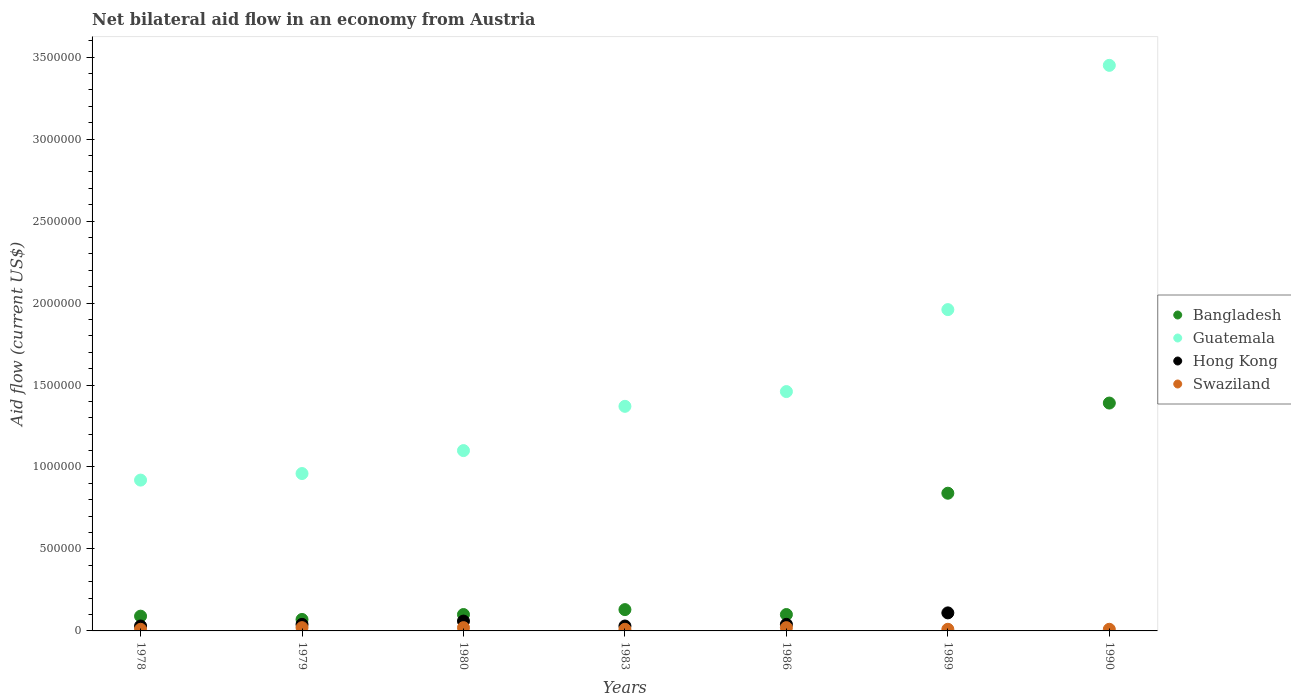Is the number of dotlines equal to the number of legend labels?
Give a very brief answer. No. Across all years, what is the maximum net bilateral aid flow in Guatemala?
Ensure brevity in your answer.  3.45e+06. What is the total net bilateral aid flow in Hong Kong in the graph?
Provide a succinct answer. 3.10e+05. What is the difference between the net bilateral aid flow in Guatemala in 1979 and the net bilateral aid flow in Swaziland in 1980?
Your response must be concise. 9.40e+05. What is the average net bilateral aid flow in Bangladesh per year?
Your response must be concise. 3.89e+05. In the year 1983, what is the difference between the net bilateral aid flow in Swaziland and net bilateral aid flow in Bangladesh?
Your answer should be compact. -1.20e+05. In how many years, is the net bilateral aid flow in Guatemala greater than 3100000 US$?
Give a very brief answer. 1. What is the ratio of the net bilateral aid flow in Bangladesh in 1978 to that in 1983?
Your answer should be very brief. 0.69. Is the net bilateral aid flow in Swaziland in 1983 less than that in 1990?
Offer a terse response. No. Is the difference between the net bilateral aid flow in Swaziland in 1989 and 1990 greater than the difference between the net bilateral aid flow in Bangladesh in 1989 and 1990?
Provide a short and direct response. Yes. What is the difference between the highest and the second highest net bilateral aid flow in Swaziland?
Give a very brief answer. 0. What is the difference between the highest and the lowest net bilateral aid flow in Guatemala?
Give a very brief answer. 2.53e+06. In how many years, is the net bilateral aid flow in Guatemala greater than the average net bilateral aid flow in Guatemala taken over all years?
Offer a terse response. 2. Is the sum of the net bilateral aid flow in Swaziland in 1983 and 1990 greater than the maximum net bilateral aid flow in Bangladesh across all years?
Ensure brevity in your answer.  No. Is it the case that in every year, the sum of the net bilateral aid flow in Guatemala and net bilateral aid flow in Bangladesh  is greater than the sum of net bilateral aid flow in Hong Kong and net bilateral aid flow in Swaziland?
Keep it short and to the point. No. Is the net bilateral aid flow in Hong Kong strictly greater than the net bilateral aid flow in Bangladesh over the years?
Your answer should be very brief. No. How many dotlines are there?
Give a very brief answer. 4. Are the values on the major ticks of Y-axis written in scientific E-notation?
Offer a terse response. No. Does the graph contain any zero values?
Your answer should be compact. Yes. How many legend labels are there?
Your answer should be very brief. 4. How are the legend labels stacked?
Keep it short and to the point. Vertical. What is the title of the graph?
Your response must be concise. Net bilateral aid flow in an economy from Austria. Does "Montenegro" appear as one of the legend labels in the graph?
Offer a very short reply. No. What is the label or title of the X-axis?
Give a very brief answer. Years. What is the Aid flow (current US$) of Bangladesh in 1978?
Provide a short and direct response. 9.00e+04. What is the Aid flow (current US$) of Guatemala in 1978?
Offer a terse response. 9.20e+05. What is the Aid flow (current US$) in Guatemala in 1979?
Provide a succinct answer. 9.60e+05. What is the Aid flow (current US$) of Hong Kong in 1979?
Provide a succinct answer. 4.00e+04. What is the Aid flow (current US$) of Swaziland in 1979?
Ensure brevity in your answer.  2.00e+04. What is the Aid flow (current US$) of Bangladesh in 1980?
Keep it short and to the point. 1.00e+05. What is the Aid flow (current US$) in Guatemala in 1980?
Your response must be concise. 1.10e+06. What is the Aid flow (current US$) in Hong Kong in 1980?
Provide a short and direct response. 6.00e+04. What is the Aid flow (current US$) in Guatemala in 1983?
Your response must be concise. 1.37e+06. What is the Aid flow (current US$) of Guatemala in 1986?
Provide a short and direct response. 1.46e+06. What is the Aid flow (current US$) in Swaziland in 1986?
Offer a terse response. 2.00e+04. What is the Aid flow (current US$) of Bangladesh in 1989?
Ensure brevity in your answer.  8.40e+05. What is the Aid flow (current US$) of Guatemala in 1989?
Keep it short and to the point. 1.96e+06. What is the Aid flow (current US$) in Bangladesh in 1990?
Offer a terse response. 1.39e+06. What is the Aid flow (current US$) of Guatemala in 1990?
Offer a very short reply. 3.45e+06. Across all years, what is the maximum Aid flow (current US$) in Bangladesh?
Your answer should be compact. 1.39e+06. Across all years, what is the maximum Aid flow (current US$) in Guatemala?
Keep it short and to the point. 3.45e+06. Across all years, what is the maximum Aid flow (current US$) in Hong Kong?
Keep it short and to the point. 1.10e+05. Across all years, what is the maximum Aid flow (current US$) in Swaziland?
Provide a short and direct response. 2.00e+04. Across all years, what is the minimum Aid flow (current US$) of Guatemala?
Your answer should be compact. 9.20e+05. What is the total Aid flow (current US$) in Bangladesh in the graph?
Your response must be concise. 2.72e+06. What is the total Aid flow (current US$) of Guatemala in the graph?
Offer a very short reply. 1.12e+07. What is the total Aid flow (current US$) in Swaziland in the graph?
Your answer should be very brief. 1.00e+05. What is the difference between the Aid flow (current US$) in Hong Kong in 1978 and that in 1979?
Your answer should be very brief. -10000. What is the difference between the Aid flow (current US$) of Swaziland in 1978 and that in 1979?
Your answer should be compact. -10000. What is the difference between the Aid flow (current US$) in Bangladesh in 1978 and that in 1980?
Your response must be concise. -10000. What is the difference between the Aid flow (current US$) in Guatemala in 1978 and that in 1980?
Provide a succinct answer. -1.80e+05. What is the difference between the Aid flow (current US$) in Guatemala in 1978 and that in 1983?
Give a very brief answer. -4.50e+05. What is the difference between the Aid flow (current US$) in Hong Kong in 1978 and that in 1983?
Your response must be concise. 0. What is the difference between the Aid flow (current US$) in Swaziland in 1978 and that in 1983?
Provide a succinct answer. 0. What is the difference between the Aid flow (current US$) in Bangladesh in 1978 and that in 1986?
Your answer should be compact. -10000. What is the difference between the Aid flow (current US$) in Guatemala in 1978 and that in 1986?
Offer a terse response. -5.40e+05. What is the difference between the Aid flow (current US$) in Swaziland in 1978 and that in 1986?
Offer a very short reply. -10000. What is the difference between the Aid flow (current US$) of Bangladesh in 1978 and that in 1989?
Keep it short and to the point. -7.50e+05. What is the difference between the Aid flow (current US$) of Guatemala in 1978 and that in 1989?
Give a very brief answer. -1.04e+06. What is the difference between the Aid flow (current US$) of Bangladesh in 1978 and that in 1990?
Ensure brevity in your answer.  -1.30e+06. What is the difference between the Aid flow (current US$) of Guatemala in 1978 and that in 1990?
Your answer should be very brief. -2.53e+06. What is the difference between the Aid flow (current US$) of Hong Kong in 1979 and that in 1980?
Ensure brevity in your answer.  -2.00e+04. What is the difference between the Aid flow (current US$) of Swaziland in 1979 and that in 1980?
Keep it short and to the point. 0. What is the difference between the Aid flow (current US$) of Guatemala in 1979 and that in 1983?
Ensure brevity in your answer.  -4.10e+05. What is the difference between the Aid flow (current US$) in Guatemala in 1979 and that in 1986?
Provide a short and direct response. -5.00e+05. What is the difference between the Aid flow (current US$) in Swaziland in 1979 and that in 1986?
Your answer should be compact. 0. What is the difference between the Aid flow (current US$) in Bangladesh in 1979 and that in 1989?
Provide a short and direct response. -7.70e+05. What is the difference between the Aid flow (current US$) in Hong Kong in 1979 and that in 1989?
Give a very brief answer. -7.00e+04. What is the difference between the Aid flow (current US$) of Bangladesh in 1979 and that in 1990?
Your answer should be compact. -1.32e+06. What is the difference between the Aid flow (current US$) of Guatemala in 1979 and that in 1990?
Make the answer very short. -2.49e+06. What is the difference between the Aid flow (current US$) in Swaziland in 1979 and that in 1990?
Make the answer very short. 10000. What is the difference between the Aid flow (current US$) of Bangladesh in 1980 and that in 1983?
Your answer should be very brief. -3.00e+04. What is the difference between the Aid flow (current US$) in Guatemala in 1980 and that in 1983?
Your answer should be compact. -2.70e+05. What is the difference between the Aid flow (current US$) in Bangladesh in 1980 and that in 1986?
Offer a very short reply. 0. What is the difference between the Aid flow (current US$) in Guatemala in 1980 and that in 1986?
Make the answer very short. -3.60e+05. What is the difference between the Aid flow (current US$) of Hong Kong in 1980 and that in 1986?
Offer a very short reply. 2.00e+04. What is the difference between the Aid flow (current US$) in Swaziland in 1980 and that in 1986?
Give a very brief answer. 0. What is the difference between the Aid flow (current US$) of Bangladesh in 1980 and that in 1989?
Your response must be concise. -7.40e+05. What is the difference between the Aid flow (current US$) in Guatemala in 1980 and that in 1989?
Your answer should be compact. -8.60e+05. What is the difference between the Aid flow (current US$) of Swaziland in 1980 and that in 1989?
Offer a terse response. 10000. What is the difference between the Aid flow (current US$) of Bangladesh in 1980 and that in 1990?
Give a very brief answer. -1.29e+06. What is the difference between the Aid flow (current US$) of Guatemala in 1980 and that in 1990?
Your answer should be very brief. -2.35e+06. What is the difference between the Aid flow (current US$) of Swaziland in 1980 and that in 1990?
Provide a succinct answer. 10000. What is the difference between the Aid flow (current US$) of Hong Kong in 1983 and that in 1986?
Keep it short and to the point. -10000. What is the difference between the Aid flow (current US$) of Swaziland in 1983 and that in 1986?
Provide a succinct answer. -10000. What is the difference between the Aid flow (current US$) in Bangladesh in 1983 and that in 1989?
Offer a very short reply. -7.10e+05. What is the difference between the Aid flow (current US$) of Guatemala in 1983 and that in 1989?
Make the answer very short. -5.90e+05. What is the difference between the Aid flow (current US$) of Hong Kong in 1983 and that in 1989?
Ensure brevity in your answer.  -8.00e+04. What is the difference between the Aid flow (current US$) in Swaziland in 1983 and that in 1989?
Your answer should be compact. 0. What is the difference between the Aid flow (current US$) in Bangladesh in 1983 and that in 1990?
Your answer should be very brief. -1.26e+06. What is the difference between the Aid flow (current US$) in Guatemala in 1983 and that in 1990?
Offer a terse response. -2.08e+06. What is the difference between the Aid flow (current US$) in Swaziland in 1983 and that in 1990?
Give a very brief answer. 0. What is the difference between the Aid flow (current US$) in Bangladesh in 1986 and that in 1989?
Your answer should be very brief. -7.40e+05. What is the difference between the Aid flow (current US$) in Guatemala in 1986 and that in 1989?
Ensure brevity in your answer.  -5.00e+05. What is the difference between the Aid flow (current US$) of Bangladesh in 1986 and that in 1990?
Offer a terse response. -1.29e+06. What is the difference between the Aid flow (current US$) in Guatemala in 1986 and that in 1990?
Your answer should be compact. -1.99e+06. What is the difference between the Aid flow (current US$) in Bangladesh in 1989 and that in 1990?
Provide a short and direct response. -5.50e+05. What is the difference between the Aid flow (current US$) of Guatemala in 1989 and that in 1990?
Give a very brief answer. -1.49e+06. What is the difference between the Aid flow (current US$) of Bangladesh in 1978 and the Aid flow (current US$) of Guatemala in 1979?
Make the answer very short. -8.70e+05. What is the difference between the Aid flow (current US$) of Guatemala in 1978 and the Aid flow (current US$) of Hong Kong in 1979?
Provide a short and direct response. 8.80e+05. What is the difference between the Aid flow (current US$) in Guatemala in 1978 and the Aid flow (current US$) in Swaziland in 1979?
Provide a succinct answer. 9.00e+05. What is the difference between the Aid flow (current US$) in Bangladesh in 1978 and the Aid flow (current US$) in Guatemala in 1980?
Provide a succinct answer. -1.01e+06. What is the difference between the Aid flow (current US$) of Bangladesh in 1978 and the Aid flow (current US$) of Hong Kong in 1980?
Provide a succinct answer. 3.00e+04. What is the difference between the Aid flow (current US$) of Guatemala in 1978 and the Aid flow (current US$) of Hong Kong in 1980?
Keep it short and to the point. 8.60e+05. What is the difference between the Aid flow (current US$) of Hong Kong in 1978 and the Aid flow (current US$) of Swaziland in 1980?
Provide a short and direct response. 10000. What is the difference between the Aid flow (current US$) in Bangladesh in 1978 and the Aid flow (current US$) in Guatemala in 1983?
Provide a succinct answer. -1.28e+06. What is the difference between the Aid flow (current US$) of Bangladesh in 1978 and the Aid flow (current US$) of Hong Kong in 1983?
Offer a very short reply. 6.00e+04. What is the difference between the Aid flow (current US$) of Bangladesh in 1978 and the Aid flow (current US$) of Swaziland in 1983?
Your answer should be compact. 8.00e+04. What is the difference between the Aid flow (current US$) of Guatemala in 1978 and the Aid flow (current US$) of Hong Kong in 1983?
Provide a succinct answer. 8.90e+05. What is the difference between the Aid flow (current US$) of Guatemala in 1978 and the Aid flow (current US$) of Swaziland in 1983?
Offer a terse response. 9.10e+05. What is the difference between the Aid flow (current US$) in Hong Kong in 1978 and the Aid flow (current US$) in Swaziland in 1983?
Provide a succinct answer. 2.00e+04. What is the difference between the Aid flow (current US$) in Bangladesh in 1978 and the Aid flow (current US$) in Guatemala in 1986?
Provide a short and direct response. -1.37e+06. What is the difference between the Aid flow (current US$) of Bangladesh in 1978 and the Aid flow (current US$) of Swaziland in 1986?
Give a very brief answer. 7.00e+04. What is the difference between the Aid flow (current US$) of Guatemala in 1978 and the Aid flow (current US$) of Hong Kong in 1986?
Offer a very short reply. 8.80e+05. What is the difference between the Aid flow (current US$) of Guatemala in 1978 and the Aid flow (current US$) of Swaziland in 1986?
Offer a very short reply. 9.00e+05. What is the difference between the Aid flow (current US$) in Hong Kong in 1978 and the Aid flow (current US$) in Swaziland in 1986?
Ensure brevity in your answer.  10000. What is the difference between the Aid flow (current US$) in Bangladesh in 1978 and the Aid flow (current US$) in Guatemala in 1989?
Make the answer very short. -1.87e+06. What is the difference between the Aid flow (current US$) in Bangladesh in 1978 and the Aid flow (current US$) in Swaziland in 1989?
Offer a very short reply. 8.00e+04. What is the difference between the Aid flow (current US$) of Guatemala in 1978 and the Aid flow (current US$) of Hong Kong in 1989?
Your response must be concise. 8.10e+05. What is the difference between the Aid flow (current US$) of Guatemala in 1978 and the Aid flow (current US$) of Swaziland in 1989?
Your response must be concise. 9.10e+05. What is the difference between the Aid flow (current US$) in Bangladesh in 1978 and the Aid flow (current US$) in Guatemala in 1990?
Keep it short and to the point. -3.36e+06. What is the difference between the Aid flow (current US$) in Guatemala in 1978 and the Aid flow (current US$) in Swaziland in 1990?
Your answer should be very brief. 9.10e+05. What is the difference between the Aid flow (current US$) of Hong Kong in 1978 and the Aid flow (current US$) of Swaziland in 1990?
Provide a succinct answer. 2.00e+04. What is the difference between the Aid flow (current US$) of Bangladesh in 1979 and the Aid flow (current US$) of Guatemala in 1980?
Give a very brief answer. -1.03e+06. What is the difference between the Aid flow (current US$) in Guatemala in 1979 and the Aid flow (current US$) in Hong Kong in 1980?
Provide a succinct answer. 9.00e+05. What is the difference between the Aid flow (current US$) of Guatemala in 1979 and the Aid flow (current US$) of Swaziland in 1980?
Provide a short and direct response. 9.40e+05. What is the difference between the Aid flow (current US$) in Bangladesh in 1979 and the Aid flow (current US$) in Guatemala in 1983?
Make the answer very short. -1.30e+06. What is the difference between the Aid flow (current US$) in Bangladesh in 1979 and the Aid flow (current US$) in Swaziland in 1983?
Provide a short and direct response. 6.00e+04. What is the difference between the Aid flow (current US$) of Guatemala in 1979 and the Aid flow (current US$) of Hong Kong in 1983?
Give a very brief answer. 9.30e+05. What is the difference between the Aid flow (current US$) of Guatemala in 1979 and the Aid flow (current US$) of Swaziland in 1983?
Offer a terse response. 9.50e+05. What is the difference between the Aid flow (current US$) of Hong Kong in 1979 and the Aid flow (current US$) of Swaziland in 1983?
Offer a very short reply. 3.00e+04. What is the difference between the Aid flow (current US$) in Bangladesh in 1979 and the Aid flow (current US$) in Guatemala in 1986?
Give a very brief answer. -1.39e+06. What is the difference between the Aid flow (current US$) of Guatemala in 1979 and the Aid flow (current US$) of Hong Kong in 1986?
Provide a succinct answer. 9.20e+05. What is the difference between the Aid flow (current US$) in Guatemala in 1979 and the Aid flow (current US$) in Swaziland in 1986?
Provide a succinct answer. 9.40e+05. What is the difference between the Aid flow (current US$) of Bangladesh in 1979 and the Aid flow (current US$) of Guatemala in 1989?
Your response must be concise. -1.89e+06. What is the difference between the Aid flow (current US$) in Guatemala in 1979 and the Aid flow (current US$) in Hong Kong in 1989?
Your response must be concise. 8.50e+05. What is the difference between the Aid flow (current US$) of Guatemala in 1979 and the Aid flow (current US$) of Swaziland in 1989?
Give a very brief answer. 9.50e+05. What is the difference between the Aid flow (current US$) of Bangladesh in 1979 and the Aid flow (current US$) of Guatemala in 1990?
Your answer should be compact. -3.38e+06. What is the difference between the Aid flow (current US$) of Bangladesh in 1979 and the Aid flow (current US$) of Swaziland in 1990?
Your answer should be very brief. 6.00e+04. What is the difference between the Aid flow (current US$) of Guatemala in 1979 and the Aid flow (current US$) of Swaziland in 1990?
Give a very brief answer. 9.50e+05. What is the difference between the Aid flow (current US$) in Bangladesh in 1980 and the Aid flow (current US$) in Guatemala in 1983?
Make the answer very short. -1.27e+06. What is the difference between the Aid flow (current US$) of Bangladesh in 1980 and the Aid flow (current US$) of Hong Kong in 1983?
Your answer should be compact. 7.00e+04. What is the difference between the Aid flow (current US$) of Guatemala in 1980 and the Aid flow (current US$) of Hong Kong in 1983?
Your response must be concise. 1.07e+06. What is the difference between the Aid flow (current US$) of Guatemala in 1980 and the Aid flow (current US$) of Swaziland in 1983?
Make the answer very short. 1.09e+06. What is the difference between the Aid flow (current US$) in Hong Kong in 1980 and the Aid flow (current US$) in Swaziland in 1983?
Your answer should be very brief. 5.00e+04. What is the difference between the Aid flow (current US$) in Bangladesh in 1980 and the Aid flow (current US$) in Guatemala in 1986?
Make the answer very short. -1.36e+06. What is the difference between the Aid flow (current US$) in Bangladesh in 1980 and the Aid flow (current US$) in Swaziland in 1986?
Ensure brevity in your answer.  8.00e+04. What is the difference between the Aid flow (current US$) of Guatemala in 1980 and the Aid flow (current US$) of Hong Kong in 1986?
Your response must be concise. 1.06e+06. What is the difference between the Aid flow (current US$) of Guatemala in 1980 and the Aid flow (current US$) of Swaziland in 1986?
Offer a very short reply. 1.08e+06. What is the difference between the Aid flow (current US$) of Bangladesh in 1980 and the Aid flow (current US$) of Guatemala in 1989?
Ensure brevity in your answer.  -1.86e+06. What is the difference between the Aid flow (current US$) in Bangladesh in 1980 and the Aid flow (current US$) in Swaziland in 1989?
Your answer should be compact. 9.00e+04. What is the difference between the Aid flow (current US$) in Guatemala in 1980 and the Aid flow (current US$) in Hong Kong in 1989?
Ensure brevity in your answer.  9.90e+05. What is the difference between the Aid flow (current US$) of Guatemala in 1980 and the Aid flow (current US$) of Swaziland in 1989?
Ensure brevity in your answer.  1.09e+06. What is the difference between the Aid flow (current US$) of Hong Kong in 1980 and the Aid flow (current US$) of Swaziland in 1989?
Offer a terse response. 5.00e+04. What is the difference between the Aid flow (current US$) in Bangladesh in 1980 and the Aid flow (current US$) in Guatemala in 1990?
Offer a terse response. -3.35e+06. What is the difference between the Aid flow (current US$) in Bangladesh in 1980 and the Aid flow (current US$) in Swaziland in 1990?
Give a very brief answer. 9.00e+04. What is the difference between the Aid flow (current US$) of Guatemala in 1980 and the Aid flow (current US$) of Swaziland in 1990?
Keep it short and to the point. 1.09e+06. What is the difference between the Aid flow (current US$) of Hong Kong in 1980 and the Aid flow (current US$) of Swaziland in 1990?
Offer a very short reply. 5.00e+04. What is the difference between the Aid flow (current US$) of Bangladesh in 1983 and the Aid flow (current US$) of Guatemala in 1986?
Provide a short and direct response. -1.33e+06. What is the difference between the Aid flow (current US$) in Bangladesh in 1983 and the Aid flow (current US$) in Hong Kong in 1986?
Make the answer very short. 9.00e+04. What is the difference between the Aid flow (current US$) of Guatemala in 1983 and the Aid flow (current US$) of Hong Kong in 1986?
Offer a terse response. 1.33e+06. What is the difference between the Aid flow (current US$) of Guatemala in 1983 and the Aid flow (current US$) of Swaziland in 1986?
Your response must be concise. 1.35e+06. What is the difference between the Aid flow (current US$) of Hong Kong in 1983 and the Aid flow (current US$) of Swaziland in 1986?
Keep it short and to the point. 10000. What is the difference between the Aid flow (current US$) in Bangladesh in 1983 and the Aid flow (current US$) in Guatemala in 1989?
Ensure brevity in your answer.  -1.83e+06. What is the difference between the Aid flow (current US$) of Bangladesh in 1983 and the Aid flow (current US$) of Hong Kong in 1989?
Offer a terse response. 2.00e+04. What is the difference between the Aid flow (current US$) in Guatemala in 1983 and the Aid flow (current US$) in Hong Kong in 1989?
Provide a short and direct response. 1.26e+06. What is the difference between the Aid flow (current US$) of Guatemala in 1983 and the Aid flow (current US$) of Swaziland in 1989?
Offer a terse response. 1.36e+06. What is the difference between the Aid flow (current US$) of Hong Kong in 1983 and the Aid flow (current US$) of Swaziland in 1989?
Offer a very short reply. 2.00e+04. What is the difference between the Aid flow (current US$) in Bangladesh in 1983 and the Aid flow (current US$) in Guatemala in 1990?
Keep it short and to the point. -3.32e+06. What is the difference between the Aid flow (current US$) in Bangladesh in 1983 and the Aid flow (current US$) in Swaziland in 1990?
Make the answer very short. 1.20e+05. What is the difference between the Aid flow (current US$) of Guatemala in 1983 and the Aid flow (current US$) of Swaziland in 1990?
Make the answer very short. 1.36e+06. What is the difference between the Aid flow (current US$) of Hong Kong in 1983 and the Aid flow (current US$) of Swaziland in 1990?
Your response must be concise. 2.00e+04. What is the difference between the Aid flow (current US$) of Bangladesh in 1986 and the Aid flow (current US$) of Guatemala in 1989?
Make the answer very short. -1.86e+06. What is the difference between the Aid flow (current US$) of Guatemala in 1986 and the Aid flow (current US$) of Hong Kong in 1989?
Ensure brevity in your answer.  1.35e+06. What is the difference between the Aid flow (current US$) in Guatemala in 1986 and the Aid flow (current US$) in Swaziland in 1989?
Your response must be concise. 1.45e+06. What is the difference between the Aid flow (current US$) of Hong Kong in 1986 and the Aid flow (current US$) of Swaziland in 1989?
Your answer should be compact. 3.00e+04. What is the difference between the Aid flow (current US$) in Bangladesh in 1986 and the Aid flow (current US$) in Guatemala in 1990?
Make the answer very short. -3.35e+06. What is the difference between the Aid flow (current US$) of Bangladesh in 1986 and the Aid flow (current US$) of Swaziland in 1990?
Your response must be concise. 9.00e+04. What is the difference between the Aid flow (current US$) in Guatemala in 1986 and the Aid flow (current US$) in Swaziland in 1990?
Ensure brevity in your answer.  1.45e+06. What is the difference between the Aid flow (current US$) of Hong Kong in 1986 and the Aid flow (current US$) of Swaziland in 1990?
Ensure brevity in your answer.  3.00e+04. What is the difference between the Aid flow (current US$) of Bangladesh in 1989 and the Aid flow (current US$) of Guatemala in 1990?
Ensure brevity in your answer.  -2.61e+06. What is the difference between the Aid flow (current US$) in Bangladesh in 1989 and the Aid flow (current US$) in Swaziland in 1990?
Offer a very short reply. 8.30e+05. What is the difference between the Aid flow (current US$) in Guatemala in 1989 and the Aid flow (current US$) in Swaziland in 1990?
Keep it short and to the point. 1.95e+06. What is the average Aid flow (current US$) of Bangladesh per year?
Your answer should be compact. 3.89e+05. What is the average Aid flow (current US$) in Guatemala per year?
Your answer should be compact. 1.60e+06. What is the average Aid flow (current US$) of Hong Kong per year?
Give a very brief answer. 4.43e+04. What is the average Aid flow (current US$) of Swaziland per year?
Provide a succinct answer. 1.43e+04. In the year 1978, what is the difference between the Aid flow (current US$) in Bangladesh and Aid flow (current US$) in Guatemala?
Offer a terse response. -8.30e+05. In the year 1978, what is the difference between the Aid flow (current US$) of Bangladesh and Aid flow (current US$) of Swaziland?
Provide a succinct answer. 8.00e+04. In the year 1978, what is the difference between the Aid flow (current US$) of Guatemala and Aid flow (current US$) of Hong Kong?
Offer a terse response. 8.90e+05. In the year 1978, what is the difference between the Aid flow (current US$) in Guatemala and Aid flow (current US$) in Swaziland?
Provide a succinct answer. 9.10e+05. In the year 1978, what is the difference between the Aid flow (current US$) of Hong Kong and Aid flow (current US$) of Swaziland?
Make the answer very short. 2.00e+04. In the year 1979, what is the difference between the Aid flow (current US$) of Bangladesh and Aid flow (current US$) of Guatemala?
Provide a short and direct response. -8.90e+05. In the year 1979, what is the difference between the Aid flow (current US$) of Bangladesh and Aid flow (current US$) of Swaziland?
Offer a very short reply. 5.00e+04. In the year 1979, what is the difference between the Aid flow (current US$) of Guatemala and Aid flow (current US$) of Hong Kong?
Keep it short and to the point. 9.20e+05. In the year 1979, what is the difference between the Aid flow (current US$) of Guatemala and Aid flow (current US$) of Swaziland?
Provide a short and direct response. 9.40e+05. In the year 1980, what is the difference between the Aid flow (current US$) of Bangladesh and Aid flow (current US$) of Guatemala?
Ensure brevity in your answer.  -1.00e+06. In the year 1980, what is the difference between the Aid flow (current US$) in Bangladesh and Aid flow (current US$) in Hong Kong?
Keep it short and to the point. 4.00e+04. In the year 1980, what is the difference between the Aid flow (current US$) of Guatemala and Aid flow (current US$) of Hong Kong?
Make the answer very short. 1.04e+06. In the year 1980, what is the difference between the Aid flow (current US$) in Guatemala and Aid flow (current US$) in Swaziland?
Provide a succinct answer. 1.08e+06. In the year 1980, what is the difference between the Aid flow (current US$) in Hong Kong and Aid flow (current US$) in Swaziland?
Your response must be concise. 4.00e+04. In the year 1983, what is the difference between the Aid flow (current US$) in Bangladesh and Aid flow (current US$) in Guatemala?
Make the answer very short. -1.24e+06. In the year 1983, what is the difference between the Aid flow (current US$) in Guatemala and Aid flow (current US$) in Hong Kong?
Provide a short and direct response. 1.34e+06. In the year 1983, what is the difference between the Aid flow (current US$) of Guatemala and Aid flow (current US$) of Swaziland?
Keep it short and to the point. 1.36e+06. In the year 1983, what is the difference between the Aid flow (current US$) of Hong Kong and Aid flow (current US$) of Swaziland?
Give a very brief answer. 2.00e+04. In the year 1986, what is the difference between the Aid flow (current US$) of Bangladesh and Aid flow (current US$) of Guatemala?
Your answer should be very brief. -1.36e+06. In the year 1986, what is the difference between the Aid flow (current US$) in Bangladesh and Aid flow (current US$) in Hong Kong?
Provide a succinct answer. 6.00e+04. In the year 1986, what is the difference between the Aid flow (current US$) in Guatemala and Aid flow (current US$) in Hong Kong?
Your answer should be compact. 1.42e+06. In the year 1986, what is the difference between the Aid flow (current US$) of Guatemala and Aid flow (current US$) of Swaziland?
Ensure brevity in your answer.  1.44e+06. In the year 1989, what is the difference between the Aid flow (current US$) in Bangladesh and Aid flow (current US$) in Guatemala?
Your response must be concise. -1.12e+06. In the year 1989, what is the difference between the Aid flow (current US$) in Bangladesh and Aid flow (current US$) in Hong Kong?
Provide a succinct answer. 7.30e+05. In the year 1989, what is the difference between the Aid flow (current US$) of Bangladesh and Aid flow (current US$) of Swaziland?
Make the answer very short. 8.30e+05. In the year 1989, what is the difference between the Aid flow (current US$) in Guatemala and Aid flow (current US$) in Hong Kong?
Offer a very short reply. 1.85e+06. In the year 1989, what is the difference between the Aid flow (current US$) of Guatemala and Aid flow (current US$) of Swaziland?
Ensure brevity in your answer.  1.95e+06. In the year 1989, what is the difference between the Aid flow (current US$) of Hong Kong and Aid flow (current US$) of Swaziland?
Keep it short and to the point. 1.00e+05. In the year 1990, what is the difference between the Aid flow (current US$) in Bangladesh and Aid flow (current US$) in Guatemala?
Your answer should be compact. -2.06e+06. In the year 1990, what is the difference between the Aid flow (current US$) of Bangladesh and Aid flow (current US$) of Swaziland?
Provide a succinct answer. 1.38e+06. In the year 1990, what is the difference between the Aid flow (current US$) in Guatemala and Aid flow (current US$) in Swaziland?
Your answer should be very brief. 3.44e+06. What is the ratio of the Aid flow (current US$) of Bangladesh in 1978 to that in 1979?
Your answer should be very brief. 1.29. What is the ratio of the Aid flow (current US$) in Guatemala in 1978 to that in 1979?
Your response must be concise. 0.96. What is the ratio of the Aid flow (current US$) of Swaziland in 1978 to that in 1979?
Make the answer very short. 0.5. What is the ratio of the Aid flow (current US$) in Bangladesh in 1978 to that in 1980?
Keep it short and to the point. 0.9. What is the ratio of the Aid flow (current US$) of Guatemala in 1978 to that in 1980?
Your answer should be very brief. 0.84. What is the ratio of the Aid flow (current US$) in Hong Kong in 1978 to that in 1980?
Provide a short and direct response. 0.5. What is the ratio of the Aid flow (current US$) of Swaziland in 1978 to that in 1980?
Your response must be concise. 0.5. What is the ratio of the Aid flow (current US$) of Bangladesh in 1978 to that in 1983?
Provide a succinct answer. 0.69. What is the ratio of the Aid flow (current US$) in Guatemala in 1978 to that in 1983?
Keep it short and to the point. 0.67. What is the ratio of the Aid flow (current US$) in Swaziland in 1978 to that in 1983?
Ensure brevity in your answer.  1. What is the ratio of the Aid flow (current US$) of Bangladesh in 1978 to that in 1986?
Give a very brief answer. 0.9. What is the ratio of the Aid flow (current US$) of Guatemala in 1978 to that in 1986?
Offer a terse response. 0.63. What is the ratio of the Aid flow (current US$) of Hong Kong in 1978 to that in 1986?
Your answer should be very brief. 0.75. What is the ratio of the Aid flow (current US$) in Bangladesh in 1978 to that in 1989?
Ensure brevity in your answer.  0.11. What is the ratio of the Aid flow (current US$) of Guatemala in 1978 to that in 1989?
Offer a terse response. 0.47. What is the ratio of the Aid flow (current US$) of Hong Kong in 1978 to that in 1989?
Make the answer very short. 0.27. What is the ratio of the Aid flow (current US$) of Bangladesh in 1978 to that in 1990?
Offer a terse response. 0.06. What is the ratio of the Aid flow (current US$) in Guatemala in 1978 to that in 1990?
Your response must be concise. 0.27. What is the ratio of the Aid flow (current US$) of Swaziland in 1978 to that in 1990?
Your answer should be compact. 1. What is the ratio of the Aid flow (current US$) in Guatemala in 1979 to that in 1980?
Make the answer very short. 0.87. What is the ratio of the Aid flow (current US$) of Hong Kong in 1979 to that in 1980?
Keep it short and to the point. 0.67. What is the ratio of the Aid flow (current US$) of Swaziland in 1979 to that in 1980?
Your answer should be very brief. 1. What is the ratio of the Aid flow (current US$) in Bangladesh in 1979 to that in 1983?
Make the answer very short. 0.54. What is the ratio of the Aid flow (current US$) of Guatemala in 1979 to that in 1983?
Ensure brevity in your answer.  0.7. What is the ratio of the Aid flow (current US$) in Swaziland in 1979 to that in 1983?
Offer a very short reply. 2. What is the ratio of the Aid flow (current US$) in Guatemala in 1979 to that in 1986?
Offer a terse response. 0.66. What is the ratio of the Aid flow (current US$) of Hong Kong in 1979 to that in 1986?
Offer a terse response. 1. What is the ratio of the Aid flow (current US$) in Bangladesh in 1979 to that in 1989?
Your answer should be very brief. 0.08. What is the ratio of the Aid flow (current US$) of Guatemala in 1979 to that in 1989?
Offer a terse response. 0.49. What is the ratio of the Aid flow (current US$) of Hong Kong in 1979 to that in 1989?
Give a very brief answer. 0.36. What is the ratio of the Aid flow (current US$) of Bangladesh in 1979 to that in 1990?
Your answer should be compact. 0.05. What is the ratio of the Aid flow (current US$) in Guatemala in 1979 to that in 1990?
Give a very brief answer. 0.28. What is the ratio of the Aid flow (current US$) in Bangladesh in 1980 to that in 1983?
Ensure brevity in your answer.  0.77. What is the ratio of the Aid flow (current US$) of Guatemala in 1980 to that in 1983?
Your answer should be very brief. 0.8. What is the ratio of the Aid flow (current US$) in Swaziland in 1980 to that in 1983?
Provide a short and direct response. 2. What is the ratio of the Aid flow (current US$) in Bangladesh in 1980 to that in 1986?
Offer a terse response. 1. What is the ratio of the Aid flow (current US$) in Guatemala in 1980 to that in 1986?
Your answer should be compact. 0.75. What is the ratio of the Aid flow (current US$) of Hong Kong in 1980 to that in 1986?
Ensure brevity in your answer.  1.5. What is the ratio of the Aid flow (current US$) in Bangladesh in 1980 to that in 1989?
Offer a terse response. 0.12. What is the ratio of the Aid flow (current US$) in Guatemala in 1980 to that in 1989?
Ensure brevity in your answer.  0.56. What is the ratio of the Aid flow (current US$) of Hong Kong in 1980 to that in 1989?
Provide a succinct answer. 0.55. What is the ratio of the Aid flow (current US$) in Swaziland in 1980 to that in 1989?
Offer a terse response. 2. What is the ratio of the Aid flow (current US$) of Bangladesh in 1980 to that in 1990?
Make the answer very short. 0.07. What is the ratio of the Aid flow (current US$) in Guatemala in 1980 to that in 1990?
Ensure brevity in your answer.  0.32. What is the ratio of the Aid flow (current US$) of Guatemala in 1983 to that in 1986?
Provide a short and direct response. 0.94. What is the ratio of the Aid flow (current US$) in Hong Kong in 1983 to that in 1986?
Offer a terse response. 0.75. What is the ratio of the Aid flow (current US$) in Swaziland in 1983 to that in 1986?
Provide a short and direct response. 0.5. What is the ratio of the Aid flow (current US$) of Bangladesh in 1983 to that in 1989?
Keep it short and to the point. 0.15. What is the ratio of the Aid flow (current US$) in Guatemala in 1983 to that in 1989?
Your answer should be very brief. 0.7. What is the ratio of the Aid flow (current US$) in Hong Kong in 1983 to that in 1989?
Offer a terse response. 0.27. What is the ratio of the Aid flow (current US$) of Bangladesh in 1983 to that in 1990?
Keep it short and to the point. 0.09. What is the ratio of the Aid flow (current US$) of Guatemala in 1983 to that in 1990?
Offer a very short reply. 0.4. What is the ratio of the Aid flow (current US$) in Bangladesh in 1986 to that in 1989?
Your answer should be very brief. 0.12. What is the ratio of the Aid flow (current US$) in Guatemala in 1986 to that in 1989?
Keep it short and to the point. 0.74. What is the ratio of the Aid flow (current US$) in Hong Kong in 1986 to that in 1989?
Provide a succinct answer. 0.36. What is the ratio of the Aid flow (current US$) of Bangladesh in 1986 to that in 1990?
Make the answer very short. 0.07. What is the ratio of the Aid flow (current US$) of Guatemala in 1986 to that in 1990?
Offer a very short reply. 0.42. What is the ratio of the Aid flow (current US$) of Swaziland in 1986 to that in 1990?
Your answer should be very brief. 2. What is the ratio of the Aid flow (current US$) in Bangladesh in 1989 to that in 1990?
Offer a terse response. 0.6. What is the ratio of the Aid flow (current US$) in Guatemala in 1989 to that in 1990?
Your response must be concise. 0.57. What is the ratio of the Aid flow (current US$) in Swaziland in 1989 to that in 1990?
Keep it short and to the point. 1. What is the difference between the highest and the second highest Aid flow (current US$) of Guatemala?
Your response must be concise. 1.49e+06. What is the difference between the highest and the second highest Aid flow (current US$) of Hong Kong?
Your answer should be compact. 5.00e+04. What is the difference between the highest and the second highest Aid flow (current US$) in Swaziland?
Keep it short and to the point. 0. What is the difference between the highest and the lowest Aid flow (current US$) in Bangladesh?
Give a very brief answer. 1.32e+06. What is the difference between the highest and the lowest Aid flow (current US$) in Guatemala?
Offer a very short reply. 2.53e+06. What is the difference between the highest and the lowest Aid flow (current US$) in Swaziland?
Your answer should be compact. 10000. 